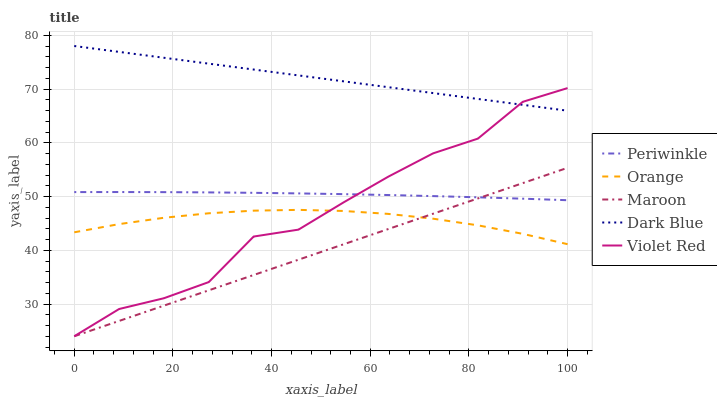Does Violet Red have the minimum area under the curve?
Answer yes or no. No. Does Violet Red have the maximum area under the curve?
Answer yes or no. No. Is Dark Blue the smoothest?
Answer yes or no. No. Is Dark Blue the roughest?
Answer yes or no. No. Does Dark Blue have the lowest value?
Answer yes or no. No. Does Violet Red have the highest value?
Answer yes or no. No. Is Periwinkle less than Dark Blue?
Answer yes or no. Yes. Is Dark Blue greater than Orange?
Answer yes or no. Yes. Does Periwinkle intersect Dark Blue?
Answer yes or no. No. 